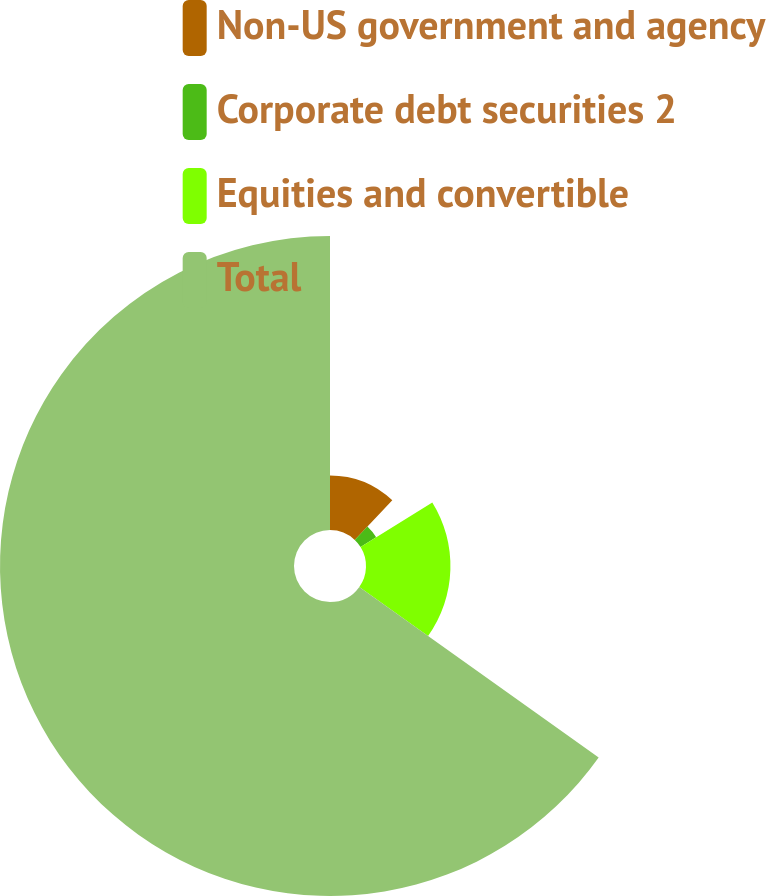Convert chart. <chart><loc_0><loc_0><loc_500><loc_500><pie_chart><fcel>Non-US government and agency<fcel>Corporate debt securities 2<fcel>Equities and convertible<fcel>Total<nl><fcel>12.08%<fcel>4.07%<fcel>18.71%<fcel>65.14%<nl></chart> 